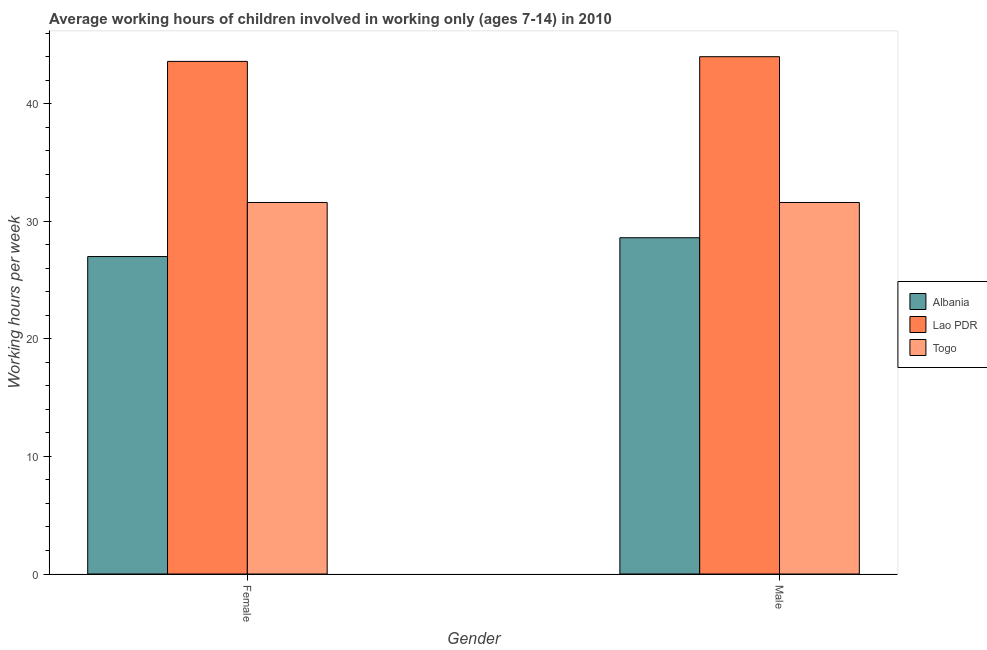How many bars are there on the 2nd tick from the left?
Keep it short and to the point. 3. What is the label of the 1st group of bars from the left?
Make the answer very short. Female. What is the average working hour of male children in Lao PDR?
Your answer should be compact. 44. Across all countries, what is the minimum average working hour of female children?
Provide a short and direct response. 27. In which country was the average working hour of female children maximum?
Keep it short and to the point. Lao PDR. In which country was the average working hour of female children minimum?
Your answer should be compact. Albania. What is the total average working hour of female children in the graph?
Give a very brief answer. 102.2. What is the difference between the average working hour of female children in Albania and that in Lao PDR?
Your answer should be very brief. -16.6. What is the difference between the average working hour of male children in Lao PDR and the average working hour of female children in Togo?
Offer a very short reply. 12.4. What is the average average working hour of female children per country?
Offer a very short reply. 34.07. What is the difference between the average working hour of male children and average working hour of female children in Albania?
Your response must be concise. 1.6. What is the ratio of the average working hour of female children in Lao PDR to that in Togo?
Make the answer very short. 1.38. Is the average working hour of female children in Lao PDR less than that in Togo?
Provide a short and direct response. No. In how many countries, is the average working hour of male children greater than the average average working hour of male children taken over all countries?
Your answer should be compact. 1. What does the 3rd bar from the left in Female represents?
Provide a short and direct response. Togo. What does the 2nd bar from the right in Male represents?
Your response must be concise. Lao PDR. Where does the legend appear in the graph?
Give a very brief answer. Center right. What is the title of the graph?
Keep it short and to the point. Average working hours of children involved in working only (ages 7-14) in 2010. Does "Canada" appear as one of the legend labels in the graph?
Ensure brevity in your answer.  No. What is the label or title of the Y-axis?
Give a very brief answer. Working hours per week. What is the Working hours per week in Lao PDR in Female?
Your answer should be compact. 43.6. What is the Working hours per week in Togo in Female?
Ensure brevity in your answer.  31.6. What is the Working hours per week in Albania in Male?
Your answer should be very brief. 28.6. What is the Working hours per week of Lao PDR in Male?
Give a very brief answer. 44. What is the Working hours per week in Togo in Male?
Your response must be concise. 31.6. Across all Gender, what is the maximum Working hours per week of Albania?
Provide a short and direct response. 28.6. Across all Gender, what is the maximum Working hours per week of Lao PDR?
Offer a very short reply. 44. Across all Gender, what is the maximum Working hours per week in Togo?
Provide a short and direct response. 31.6. Across all Gender, what is the minimum Working hours per week of Albania?
Offer a terse response. 27. Across all Gender, what is the minimum Working hours per week of Lao PDR?
Your response must be concise. 43.6. Across all Gender, what is the minimum Working hours per week of Togo?
Offer a terse response. 31.6. What is the total Working hours per week in Albania in the graph?
Ensure brevity in your answer.  55.6. What is the total Working hours per week of Lao PDR in the graph?
Your answer should be compact. 87.6. What is the total Working hours per week in Togo in the graph?
Your answer should be compact. 63.2. What is the difference between the Working hours per week in Lao PDR in Female and that in Male?
Offer a terse response. -0.4. What is the difference between the Working hours per week in Albania in Female and the Working hours per week in Lao PDR in Male?
Offer a very short reply. -17. What is the average Working hours per week in Albania per Gender?
Make the answer very short. 27.8. What is the average Working hours per week of Lao PDR per Gender?
Keep it short and to the point. 43.8. What is the average Working hours per week in Togo per Gender?
Keep it short and to the point. 31.6. What is the difference between the Working hours per week of Albania and Working hours per week of Lao PDR in Female?
Keep it short and to the point. -16.6. What is the difference between the Working hours per week of Lao PDR and Working hours per week of Togo in Female?
Provide a succinct answer. 12. What is the difference between the Working hours per week of Albania and Working hours per week of Lao PDR in Male?
Offer a terse response. -15.4. What is the difference between the Working hours per week of Albania and Working hours per week of Togo in Male?
Give a very brief answer. -3. What is the ratio of the Working hours per week in Albania in Female to that in Male?
Your response must be concise. 0.94. What is the ratio of the Working hours per week of Lao PDR in Female to that in Male?
Your answer should be compact. 0.99. What is the difference between the highest and the second highest Working hours per week in Albania?
Your answer should be compact. 1.6. What is the difference between the highest and the second highest Working hours per week of Togo?
Provide a short and direct response. 0. What is the difference between the highest and the lowest Working hours per week of Lao PDR?
Ensure brevity in your answer.  0.4. 